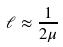<formula> <loc_0><loc_0><loc_500><loc_500>\ell \approx \frac { 1 } { 2 \mu }</formula> 